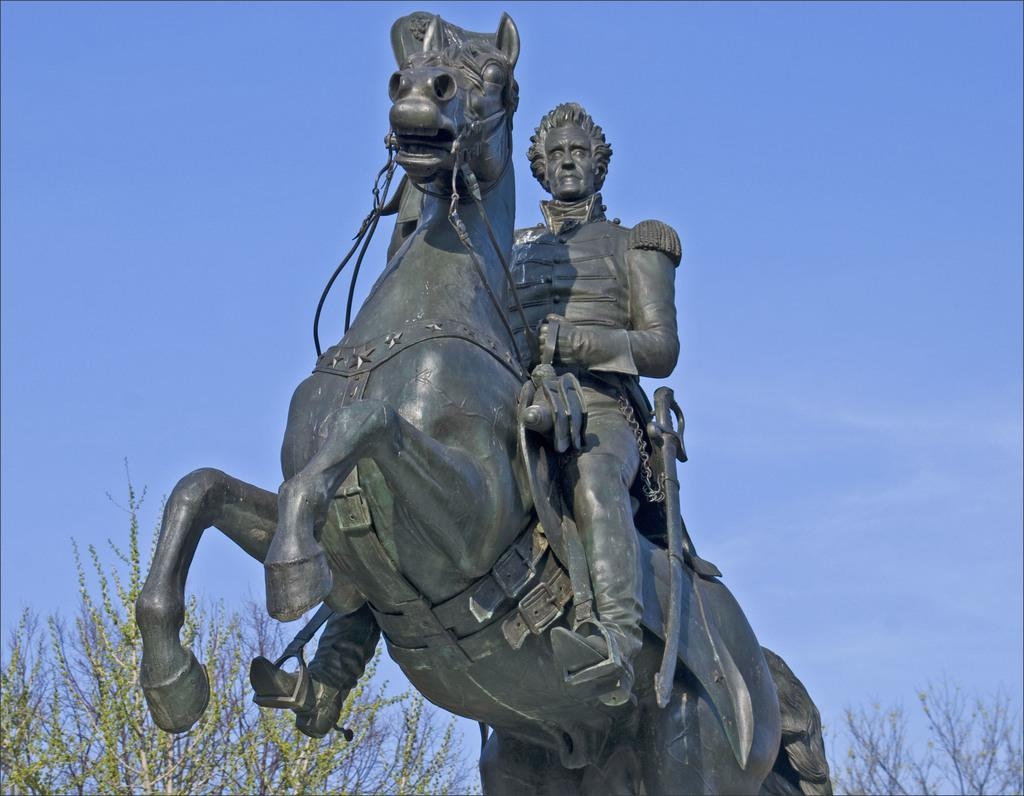What is the main subject in the image? There is a statue in the image. What can be seen in the background of the image? There are plants in the background of the image. What color is the sky in the image? The sky is blue in color. What type of ear is visible on the statue in the image? There is no ear visible on the statue in the image, as it is a statue and not a living being. 